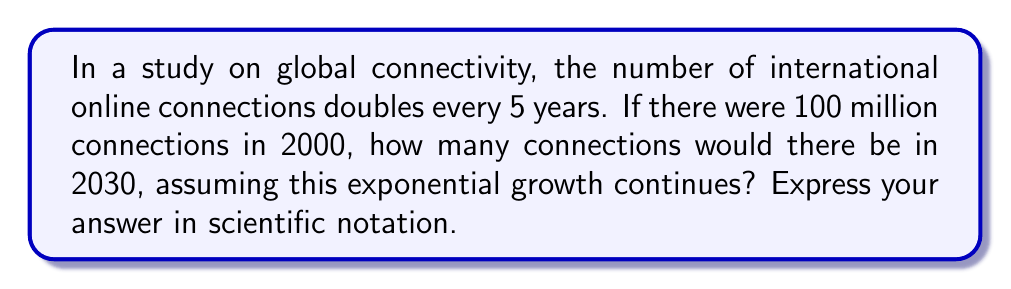Solve this math problem. Let's approach this step-by-step:

1) First, we need to determine how many 5-year periods occur between 2000 and 2030:
   $\frac{2030 - 2000}{5} = 6$ periods

2) We know that the number of connections doubles every 5 years. This means we're dealing with an exponential growth with a base of 2:
   $100 \text{ million} \times 2^6$

3) Let's calculate $2^6$:
   $2^6 = 2 \times 2 \times 2 \times 2 \times 2 \times 2 = 64$

4) Now, we multiply the initial number by this result:
   $100 \text{ million} \times 64 = 6400 \text{ million}$

5) To convert to scientific notation, we move the decimal point to get a number between 1 and 10, and adjust the exponent accordingly:
   $6400 \text{ million} = 6.4 \text{ billion} = 6.4 \times 10^9$

This exponential increase demonstrates the rapid spread of global connectivity, which significantly accelerates cultural diffusion in our interconnected world.
Answer: $6.4 \times 10^9$ 